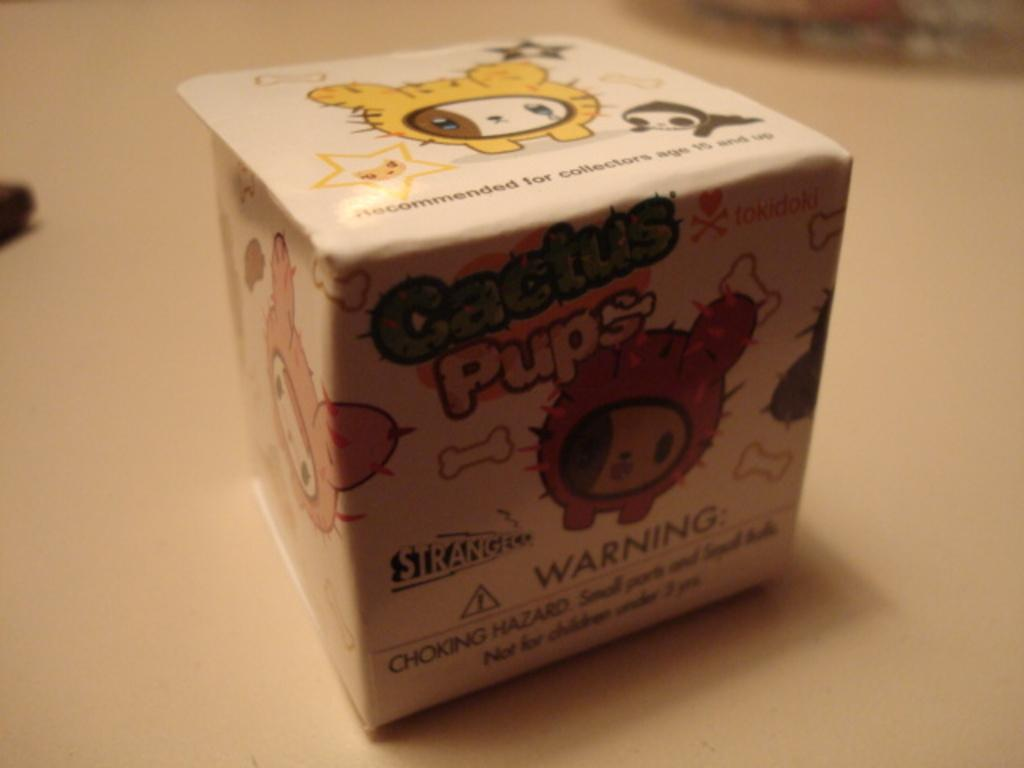<image>
Describe the image concisely. A cubic box with the word pups on it in yellow 